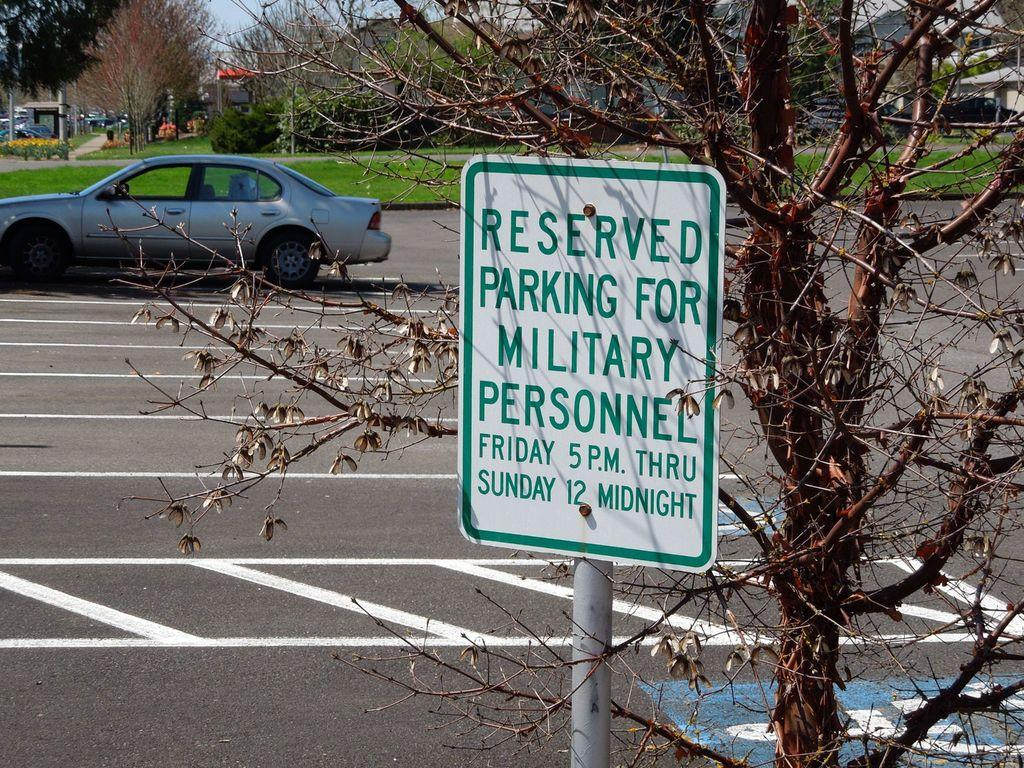What is the main object in the center of the image? There is a sign board in the center of the image. Where is the sign board located? The sign board is on the road. What can be seen in the background of the image? There are trees, a car, a road, houses, plants, and the sky visible in the background of the image. Where is the kettle located in the image? There is no kettle present in the image. What type of lunchroom can be seen in the background of the image? There is no lunchroom present in the image. 